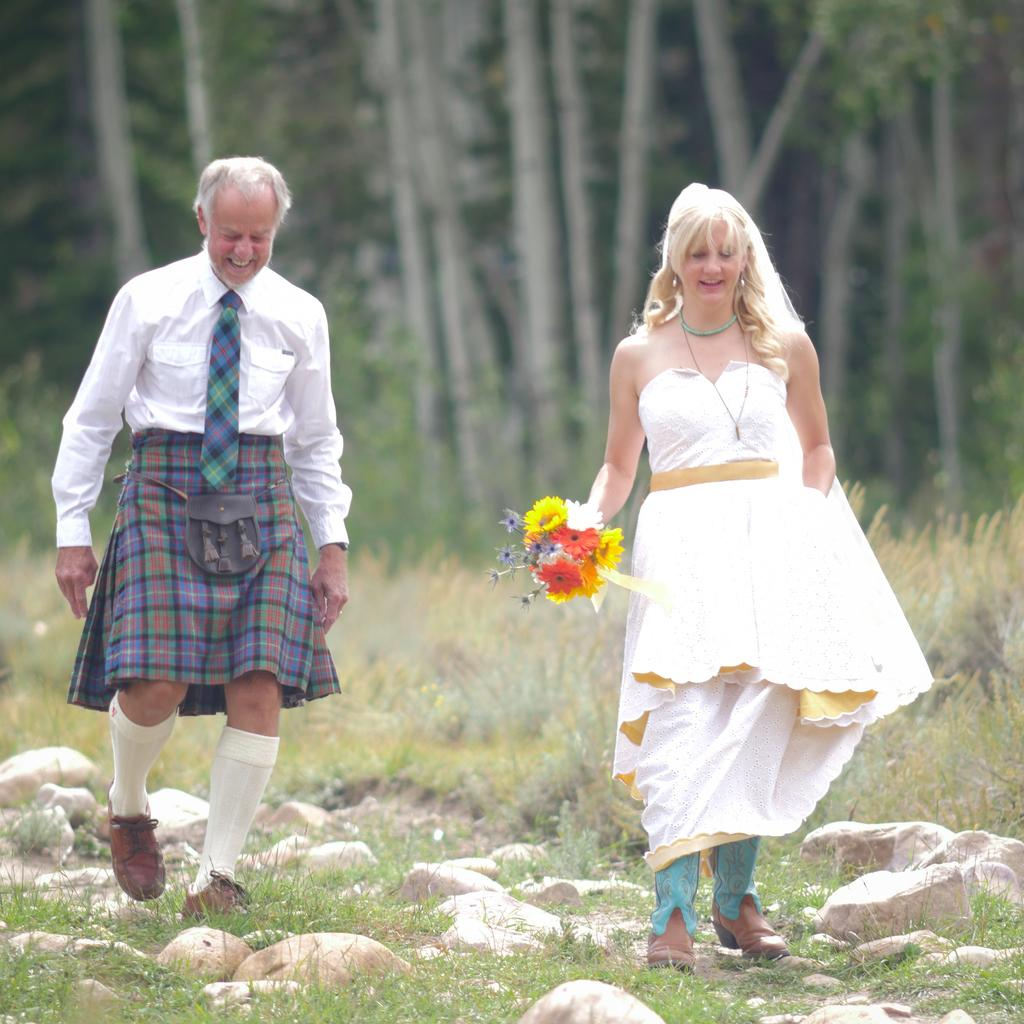What are the two persons in the image doing? The two persons in the image are walking and smiling. Can you describe the object held by one of the persons? One person is holding a flower bouquet in the image. What type of natural elements can be seen in the image? There are rocks, grass, and trees visible in the image. What type of nerve can be seen in the image? There is no nerve visible in the image. What liquid is being used to water the plants in the image? There is no liquid or watering activity depicted in the image. 